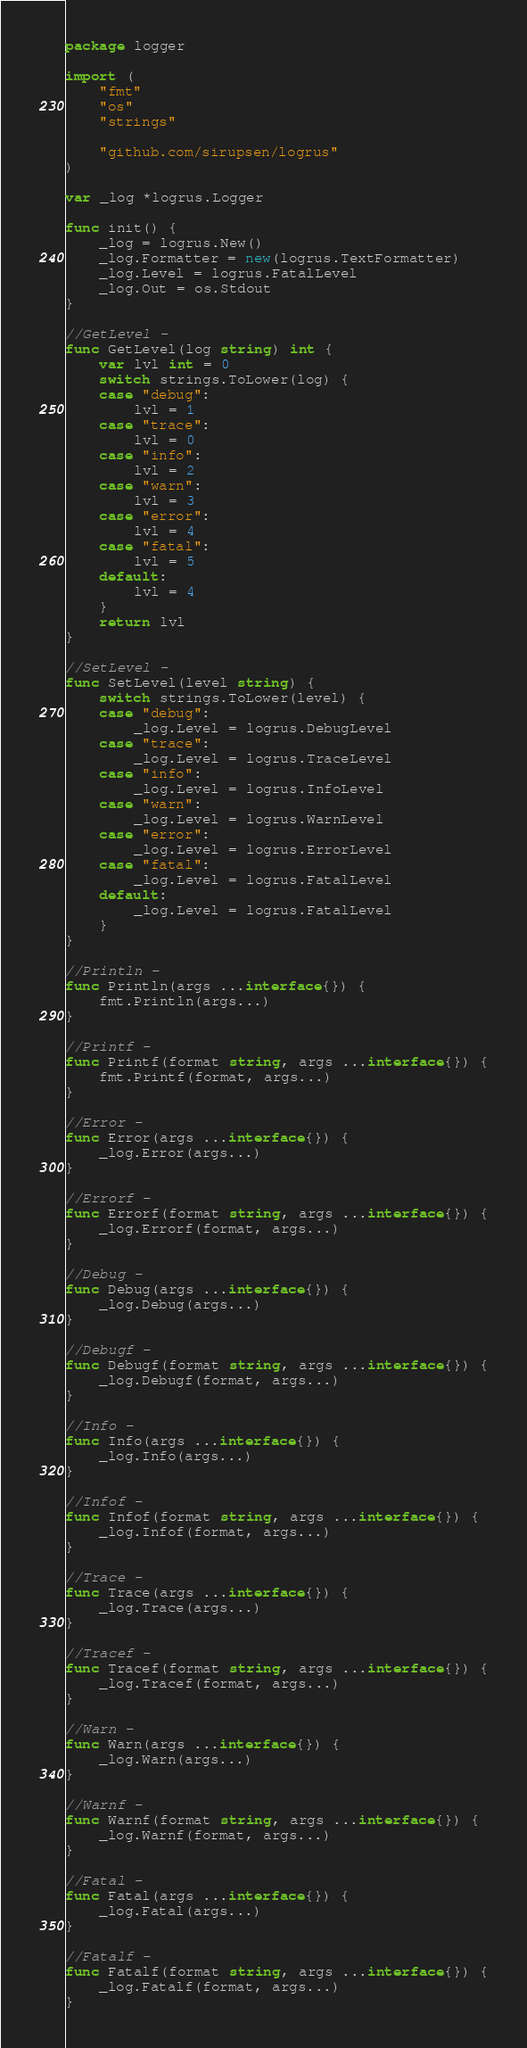<code> <loc_0><loc_0><loc_500><loc_500><_Go_>package logger

import (
	"fmt"
	"os"
	"strings"

	"github.com/sirupsen/logrus"
)

var _log *logrus.Logger

func init() {
	_log = logrus.New()
	_log.Formatter = new(logrus.TextFormatter)
	_log.Level = logrus.FatalLevel
	_log.Out = os.Stdout
}

//GetLevel -
func GetLevel(log string) int {
	var lvl int = 0
	switch strings.ToLower(log) {
	case "debug":
		lvl = 1
	case "trace":
		lvl = 0
	case "info":
		lvl = 2
	case "warn":
		lvl = 3
	case "error":
		lvl = 4
	case "fatal":
		lvl = 5
	default:
		lvl = 4
	}
	return lvl
}

//SetLevel -
func SetLevel(level string) {
	switch strings.ToLower(level) {
	case "debug":
		_log.Level = logrus.DebugLevel
	case "trace":
		_log.Level = logrus.TraceLevel
	case "info":
		_log.Level = logrus.InfoLevel
	case "warn":
		_log.Level = logrus.WarnLevel
	case "error":
		_log.Level = logrus.ErrorLevel
	case "fatal":
		_log.Level = logrus.FatalLevel
	default:
		_log.Level = logrus.FatalLevel
	}
}

//Println -
func Println(args ...interface{}) {
	fmt.Println(args...)
}

//Printf -
func Printf(format string, args ...interface{}) {
	fmt.Printf(format, args...)
}

//Error -
func Error(args ...interface{}) {
	_log.Error(args...)
}

//Errorf -
func Errorf(format string, args ...interface{}) {
	_log.Errorf(format, args...)
}

//Debug -
func Debug(args ...interface{}) {
	_log.Debug(args...)
}

//Debugf -
func Debugf(format string, args ...interface{}) {
	_log.Debugf(format, args...)
}

//Info -
func Info(args ...interface{}) {
	_log.Info(args...)
}

//Infof -
func Infof(format string, args ...interface{}) {
	_log.Infof(format, args...)
}

//Trace -
func Trace(args ...interface{}) {
	_log.Trace(args...)
}

//Tracef -
func Tracef(format string, args ...interface{}) {
	_log.Tracef(format, args...)
}

//Warn -
func Warn(args ...interface{}) {
	_log.Warn(args...)
}

//Warnf -
func Warnf(format string, args ...interface{}) {
	_log.Warnf(format, args...)
}

//Fatal -
func Fatal(args ...interface{}) {
	_log.Fatal(args...)
}

//Fatalf -
func Fatalf(format string, args ...interface{}) {
	_log.Fatalf(format, args...)
}
</code> 